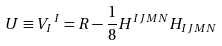<formula> <loc_0><loc_0><loc_500><loc_500>U \equiv V _ { I } \, ^ { I } = R - \frac { 1 } { 8 } H ^ { I J M N } H _ { I J M N }</formula> 